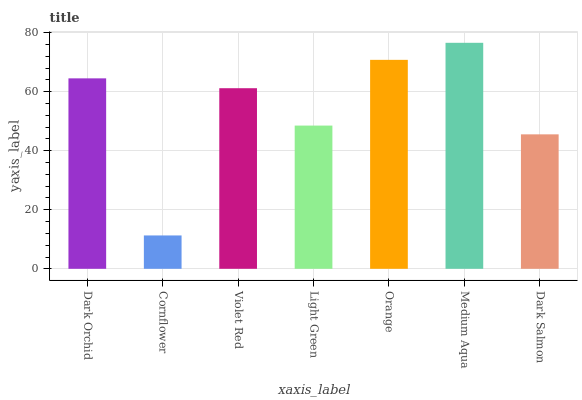Is Cornflower the minimum?
Answer yes or no. Yes. Is Medium Aqua the maximum?
Answer yes or no. Yes. Is Violet Red the minimum?
Answer yes or no. No. Is Violet Red the maximum?
Answer yes or no. No. Is Violet Red greater than Cornflower?
Answer yes or no. Yes. Is Cornflower less than Violet Red?
Answer yes or no. Yes. Is Cornflower greater than Violet Red?
Answer yes or no. No. Is Violet Red less than Cornflower?
Answer yes or no. No. Is Violet Red the high median?
Answer yes or no. Yes. Is Violet Red the low median?
Answer yes or no. Yes. Is Cornflower the high median?
Answer yes or no. No. Is Light Green the low median?
Answer yes or no. No. 